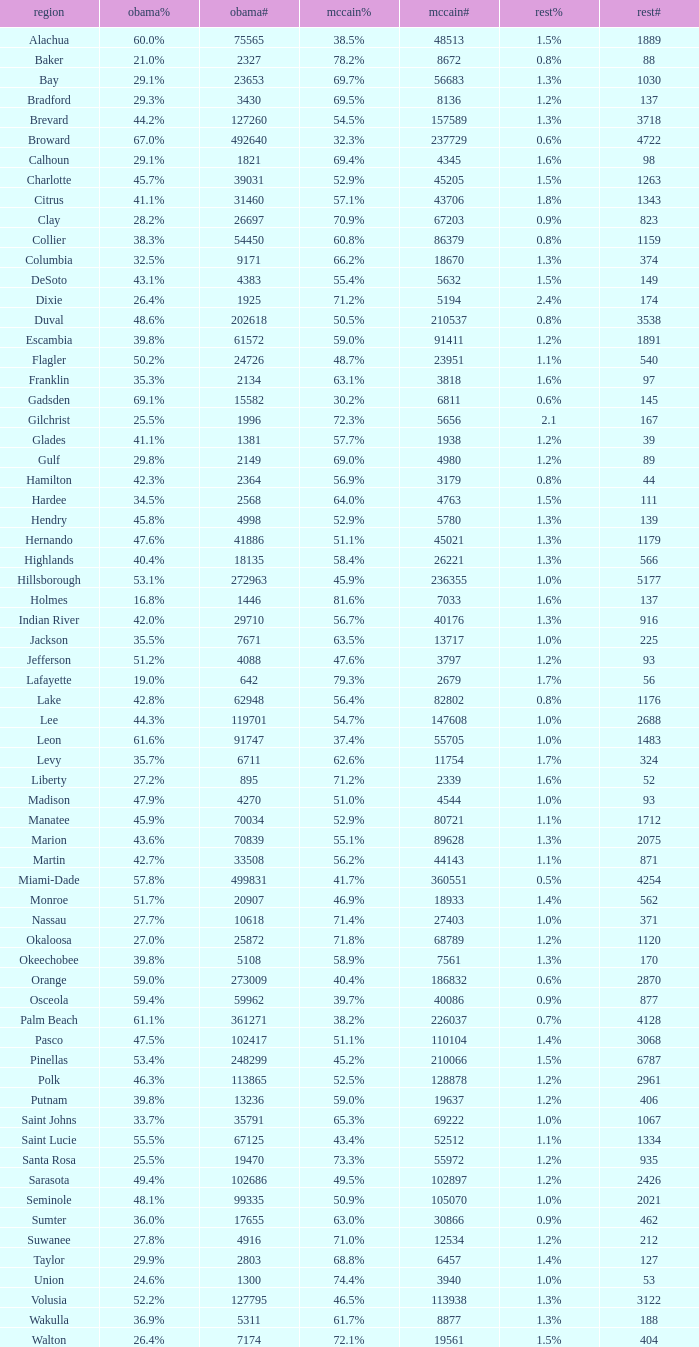How many numbers were recorded under McCain when Obama had 27.2% voters? 1.0. 